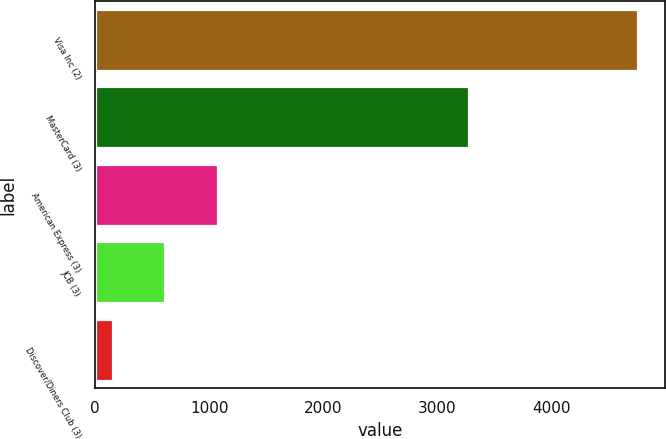Convert chart to OTSL. <chart><loc_0><loc_0><loc_500><loc_500><bar_chart><fcel>Visa Inc (2)<fcel>MasterCard (3)<fcel>American Express (3)<fcel>JCB (3)<fcel>Discover/Diners Club (3)<nl><fcel>4761<fcel>3281<fcel>1074.6<fcel>613.8<fcel>153<nl></chart> 